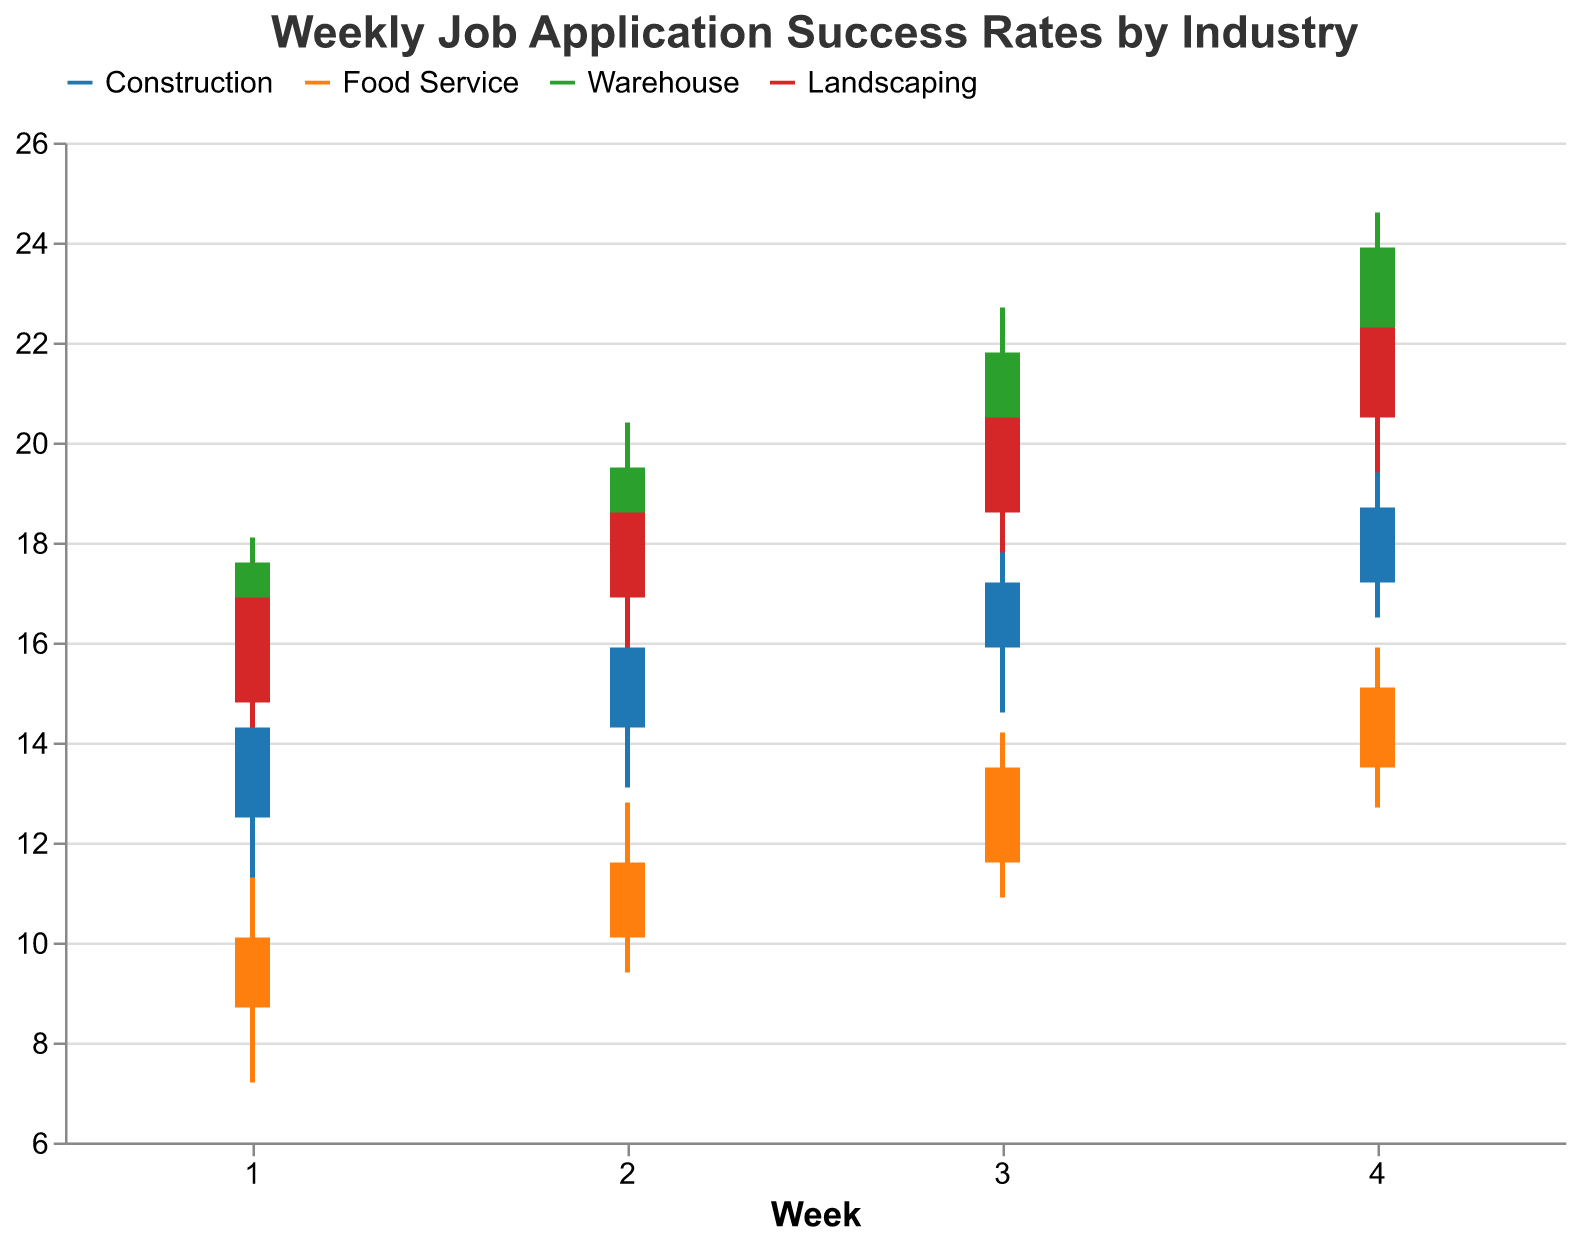What's the title of the figure? The title of the figure is typically displayed at the top and is written in a larger font compared to other text elements in the chart.
Answer: Weekly Job Application Success Rates by Industry Which industry had the highest job application success rate in Week 1? By examining the "High" values for Week 1 across all industries, we find the highest success rate. Warehouse has the highest "High" value at 18.1.
Answer: Warehouse What is the color corresponding to the Construction industry in the chart? Construction is assigned a specific color in the legend, appearing as a blue shade.
Answer: Blue By how much did the job application success rate increase in the Food Service industry from Week 1 to Week 4? The success rate went from 10.1 (Close in Week 1) to 15.1 (Close in Week 4). The increase is 15.1 - 10.1 = 5.0.
Answer: 5.0 Which industry showed the most significant increase in job application success rates by comparing the Close values from Week 1 to Week 4? Calculating the difference between Close values from Week 1 to Week 4 for each industry: Construction (18.7 - 14.3 = 4.4), Food Service (15.1 - 10.1 = 5.0), Warehouse (23.9 - 17.6 = 6.3), Landscaping (22.3 - 16.9 = 5.4). Warehouse shows the most significant increase.
Answer: Warehouse On average, what was the highest weekly job application success rate across all industries in Week 3? The highest rates (High) for Week 3 are Construction (18.4), Food Service (14.2), Warehouse (22.7), Landscaping (21.2). The average is (18.4 + 14.2 + 22.7 + 21.2) / 4 = 19.125.
Answer: 19.125 Which industry had the smallest range of job application success rates in Week 4? The range is calculated by subtracting Low from High. Values for Week 4: Construction (19.8 - 16.5 = 3.3), Food Service (15.9 - 12.7 = 3.2), Warehouse (24.6 - 20.7 = 3.9), Landscaping (23.1 - 19.4 = 3.7). Food Service had the smallest range.
Answer: Food Service Which industry had a declining trend in the job application success rates over the 4 weeks period? A declining trend means a continuous decrease in Close values. Upon inspection, none of the industries show a completely declining trend as all industries exhibit increasing Close values over the weeks.
Answer: None At any point, did the open job application success rate for Landscaping in any week exceed its close success rate? Compare the Open and Close values for Landscaping across all weeks. All Open values are less than Close values in Landscaping across all weeks: (14.8 < 16.9, 16.9 < 18.6, 18.6 < 20.5, 20.5 < 22.3).
Answer: No 